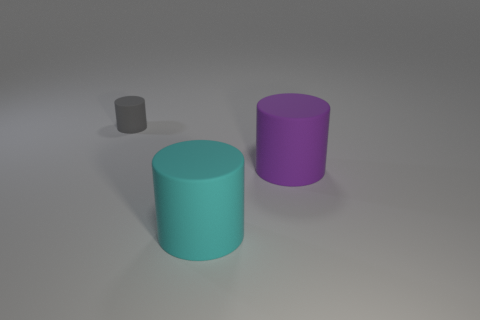Add 2 gray rubber things. How many gray rubber things exist? 3 Add 1 big purple cylinders. How many objects exist? 4 Subtract all cyan cylinders. How many cylinders are left? 2 Subtract all big purple cylinders. How many cylinders are left? 2 Subtract 0 yellow cylinders. How many objects are left? 3 Subtract all cyan cylinders. Subtract all green balls. How many cylinders are left? 2 Subtract all brown blocks. How many yellow cylinders are left? 0 Subtract all yellow matte cubes. Subtract all big cyan things. How many objects are left? 2 Add 2 cyan cylinders. How many cyan cylinders are left? 3 